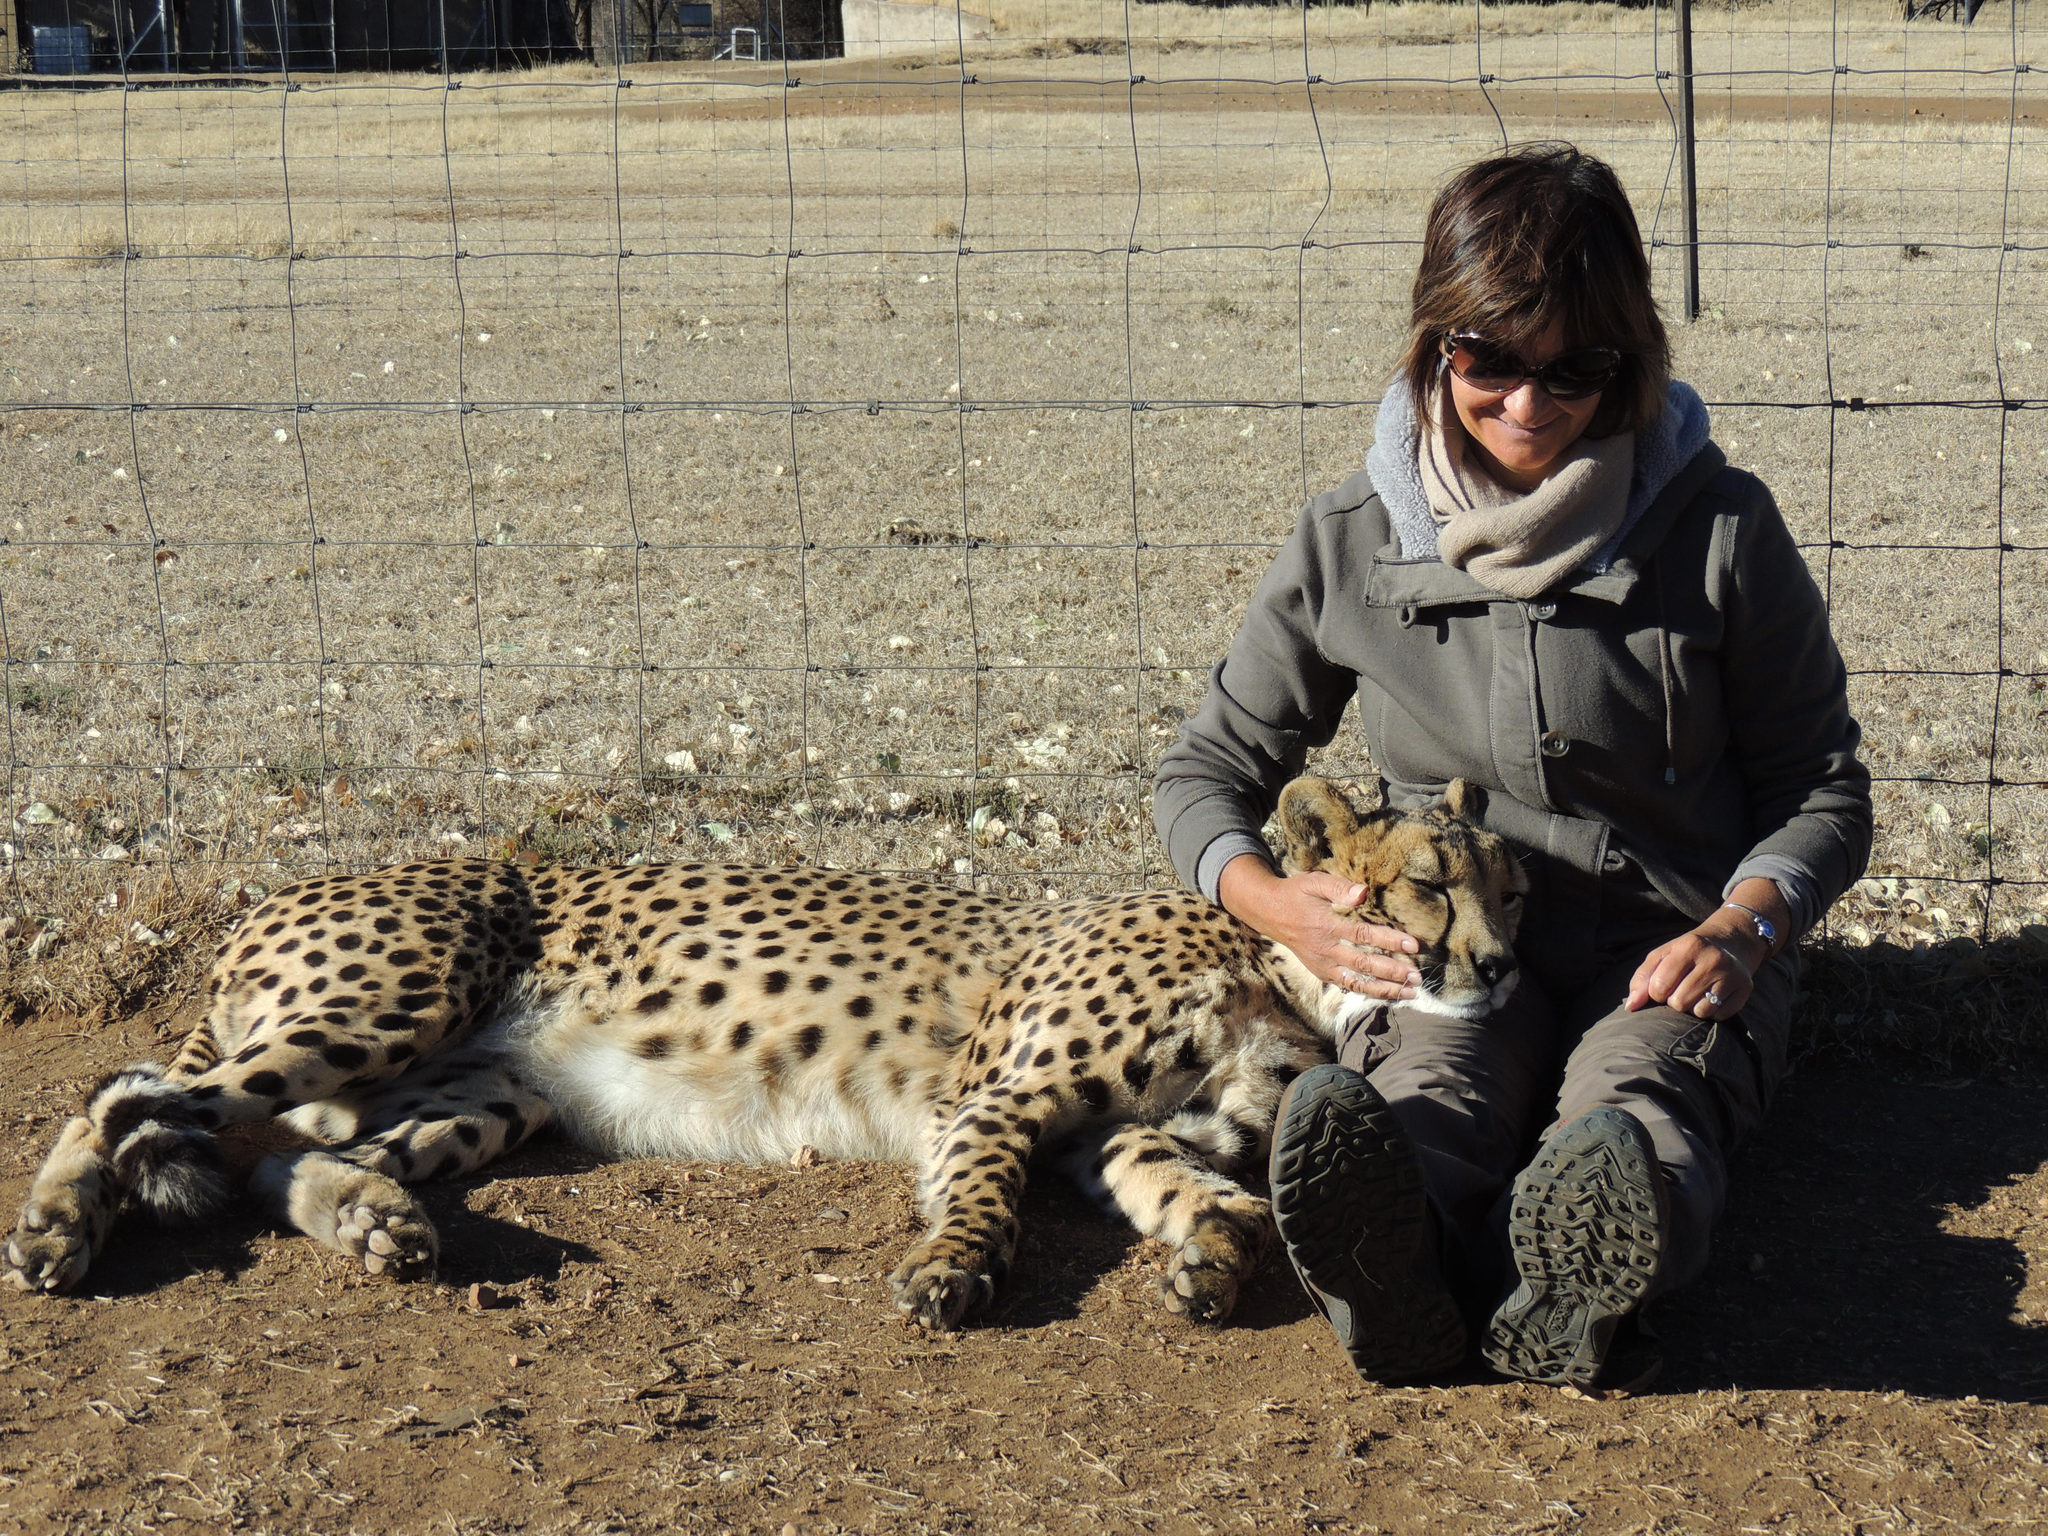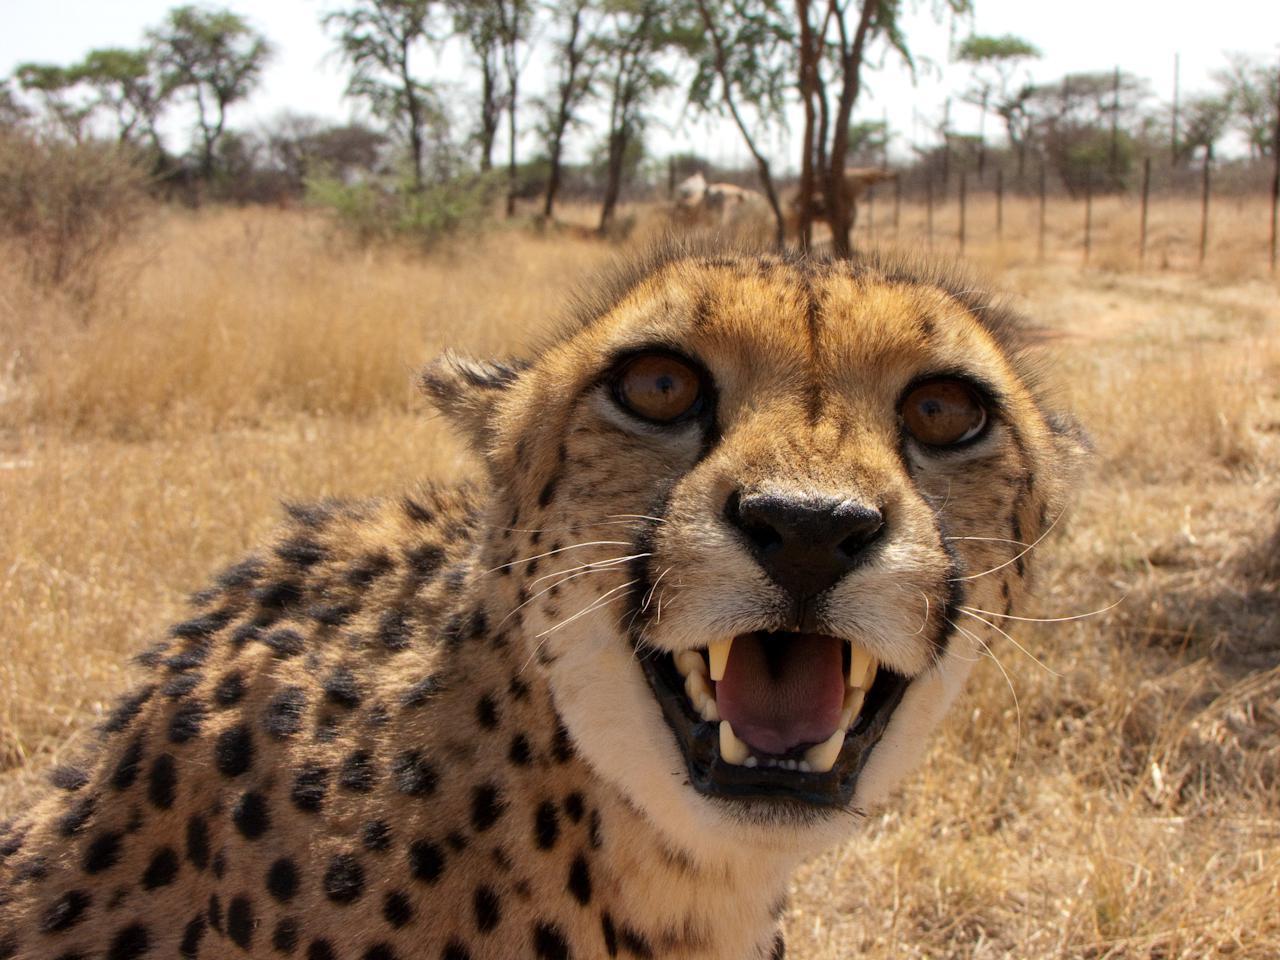The first image is the image on the left, the second image is the image on the right. Given the left and right images, does the statement "The animals are running with their front legs air bound" hold true? Answer yes or no. No. The first image is the image on the left, the second image is the image on the right. Considering the images on both sides, is "An image shows one running cheetah with front paws off the ground." valid? Answer yes or no. No. 